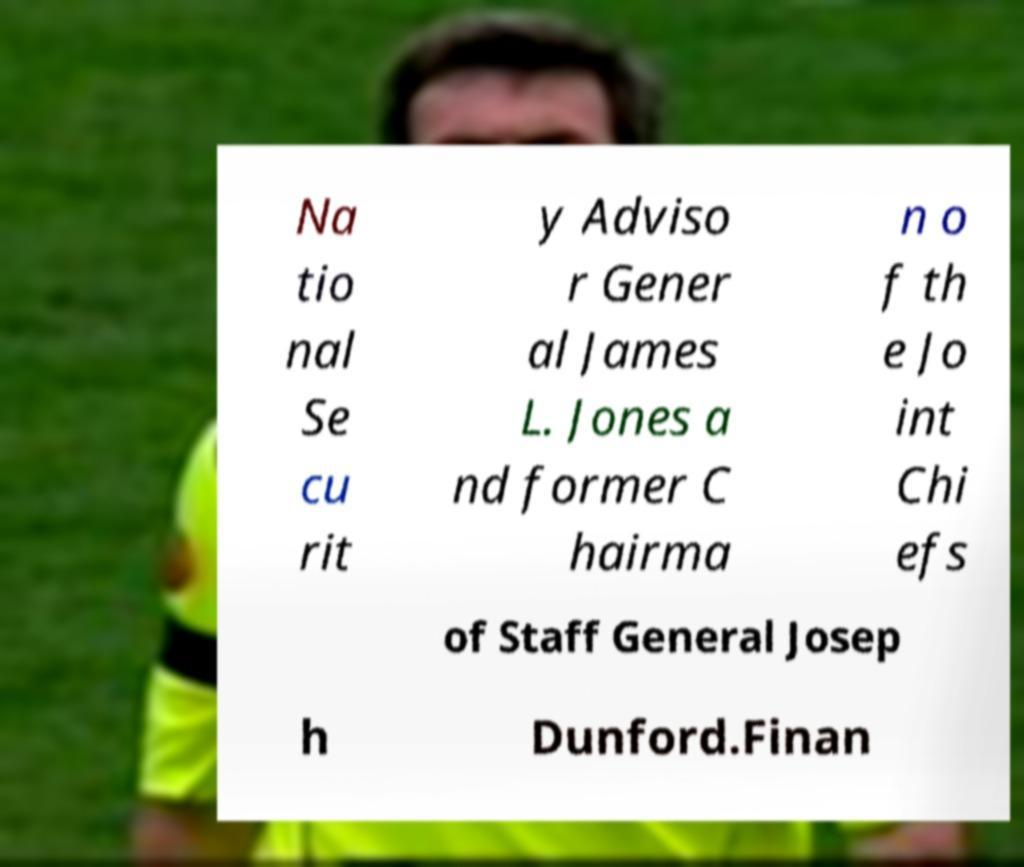Please identify and transcribe the text found in this image. Na tio nal Se cu rit y Adviso r Gener al James L. Jones a nd former C hairma n o f th e Jo int Chi efs of Staff General Josep h Dunford.Finan 